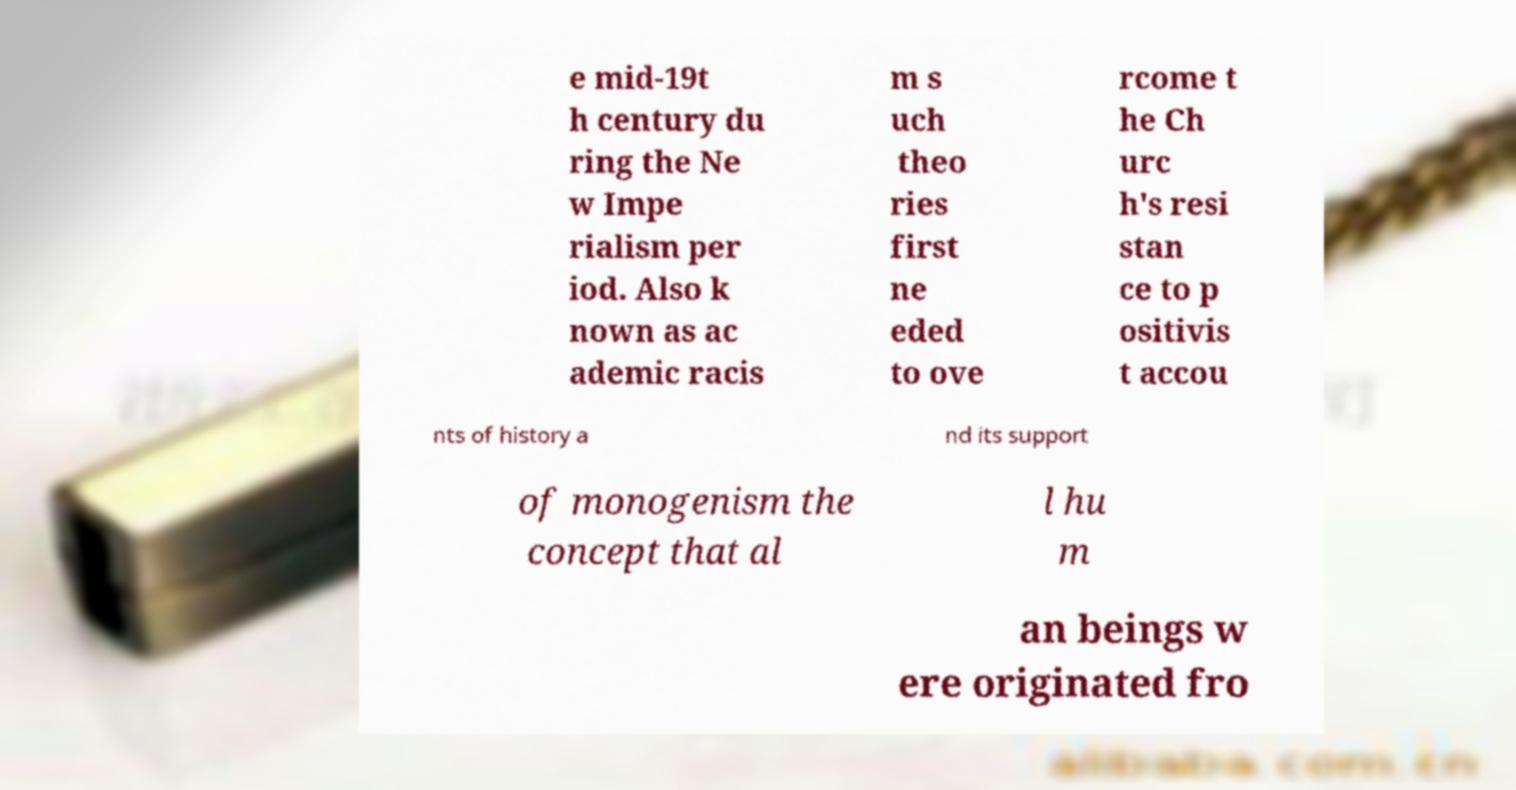Could you assist in decoding the text presented in this image and type it out clearly? e mid-19t h century du ring the Ne w Impe rialism per iod. Also k nown as ac ademic racis m s uch theo ries first ne eded to ove rcome t he Ch urc h's resi stan ce to p ositivis t accou nts of history a nd its support of monogenism the concept that al l hu m an beings w ere originated fro 